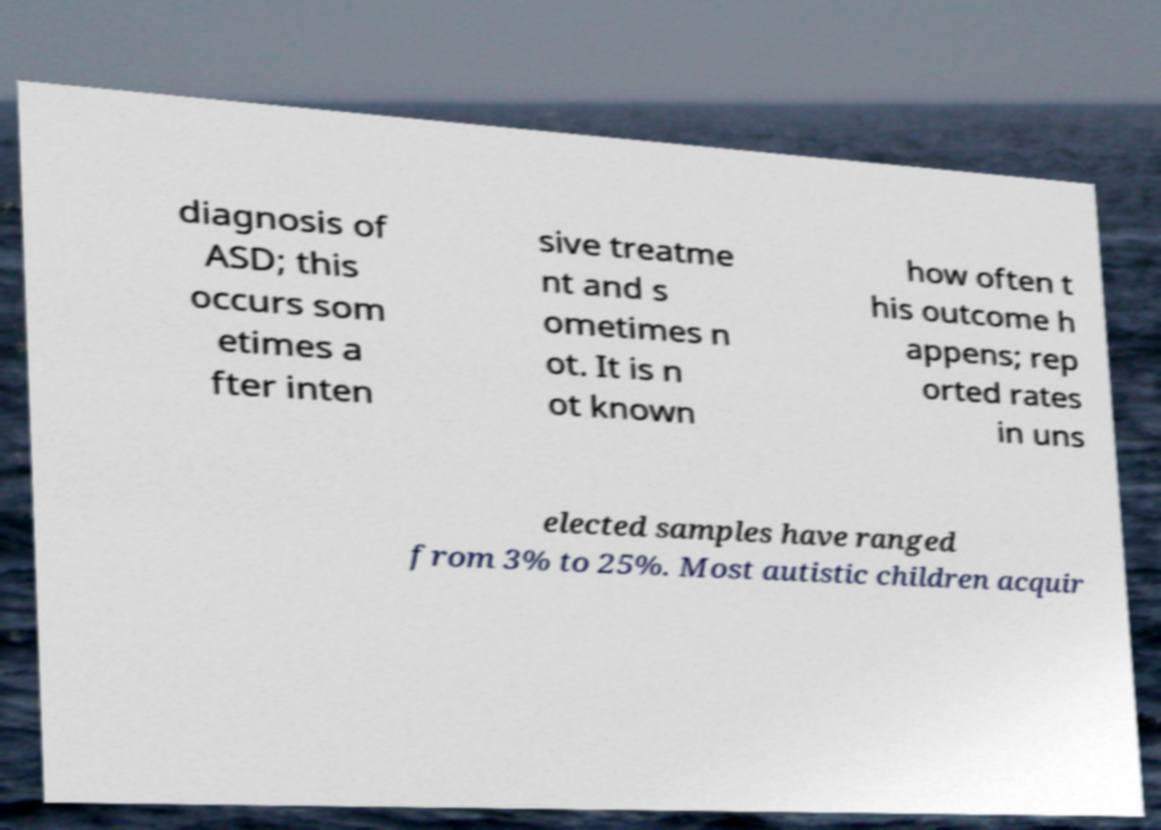Can you read and provide the text displayed in the image?This photo seems to have some interesting text. Can you extract and type it out for me? diagnosis of ASD; this occurs som etimes a fter inten sive treatme nt and s ometimes n ot. It is n ot known how often t his outcome h appens; rep orted rates in uns elected samples have ranged from 3% to 25%. Most autistic children acquir 